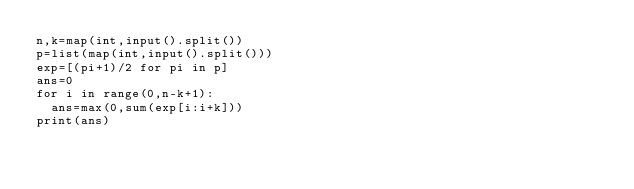<code> <loc_0><loc_0><loc_500><loc_500><_Python_>n,k=map(int,input().split())
p=list(map(int,input().split()))
exp=[(pi+1)/2 for pi in p]
ans=0
for i in range(0,n-k+1):
  ans=max(0,sum(exp[i:i+k]))
print(ans)</code> 